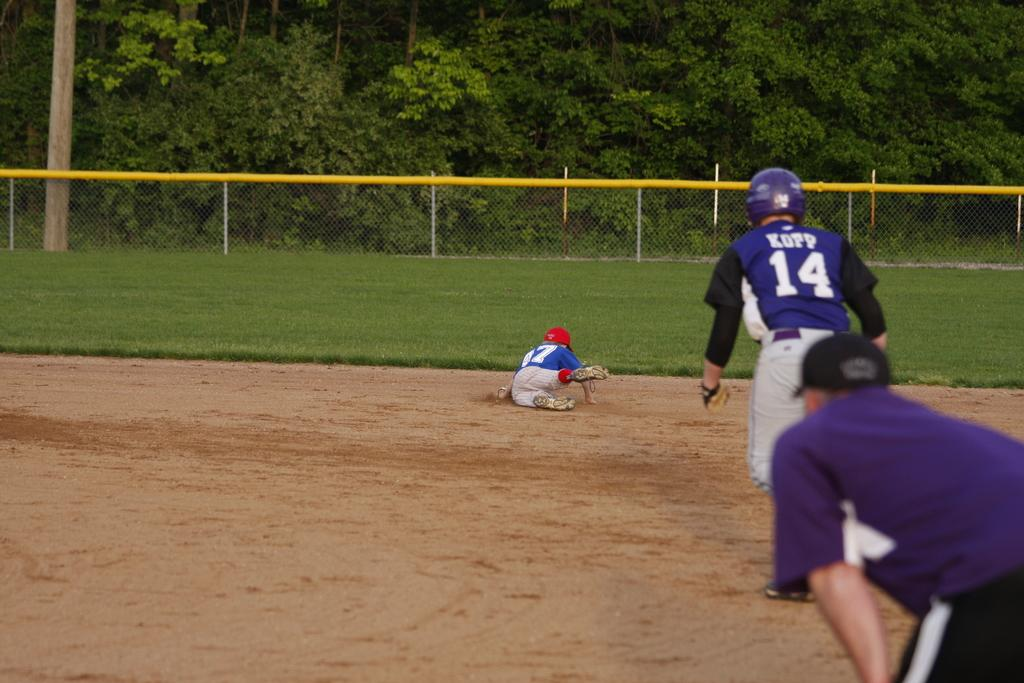<image>
Provide a brief description of the given image. Baseball player wearing number 17 sliding into base 